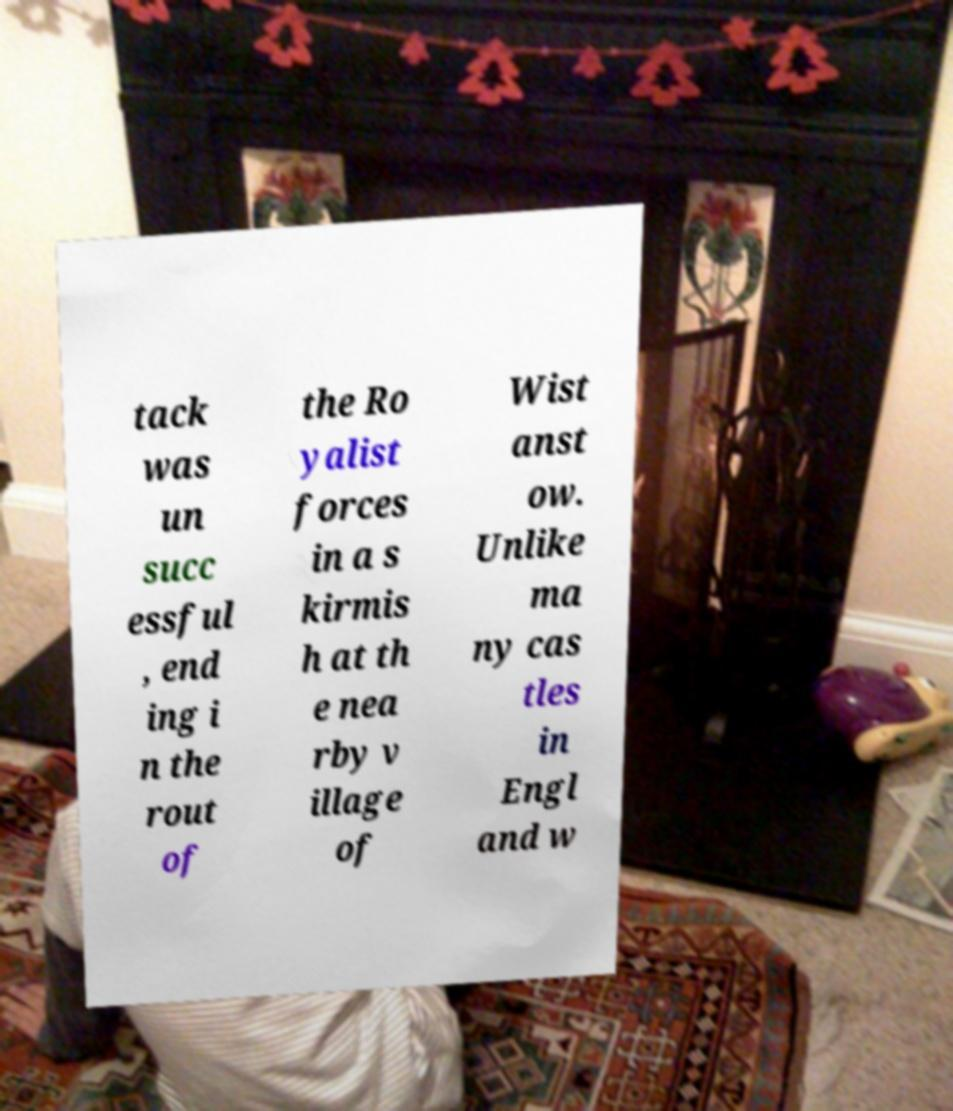Please identify and transcribe the text found in this image. tack was un succ essful , end ing i n the rout of the Ro yalist forces in a s kirmis h at th e nea rby v illage of Wist anst ow. Unlike ma ny cas tles in Engl and w 